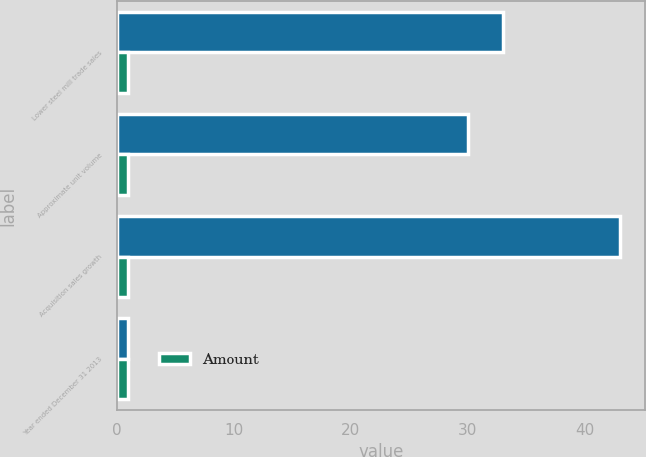Convert chart. <chart><loc_0><loc_0><loc_500><loc_500><stacked_bar_chart><ecel><fcel>Lower steel mill trade sales<fcel>Approximate unit volume<fcel>Acquisition sales growth<fcel>Year ended December 31 2013<nl><fcel>nan<fcel>33<fcel>30<fcel>43<fcel>1<nl><fcel>Amount<fcel>1<fcel>1<fcel>1<fcel>1<nl></chart> 